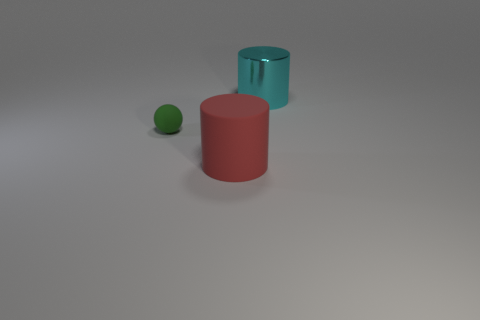Add 3 matte objects. How many objects exist? 6 Add 2 small matte balls. How many small matte balls are left? 3 Add 3 cyan shiny cylinders. How many cyan shiny cylinders exist? 4 Subtract all red cylinders. How many cylinders are left? 1 Subtract 0 purple cylinders. How many objects are left? 3 Subtract all balls. How many objects are left? 2 Subtract 1 cylinders. How many cylinders are left? 1 Subtract all blue spheres. Subtract all gray cylinders. How many spheres are left? 1 Subtract all green cylinders. How many purple spheres are left? 0 Subtract all tiny green matte spheres. Subtract all red matte things. How many objects are left? 1 